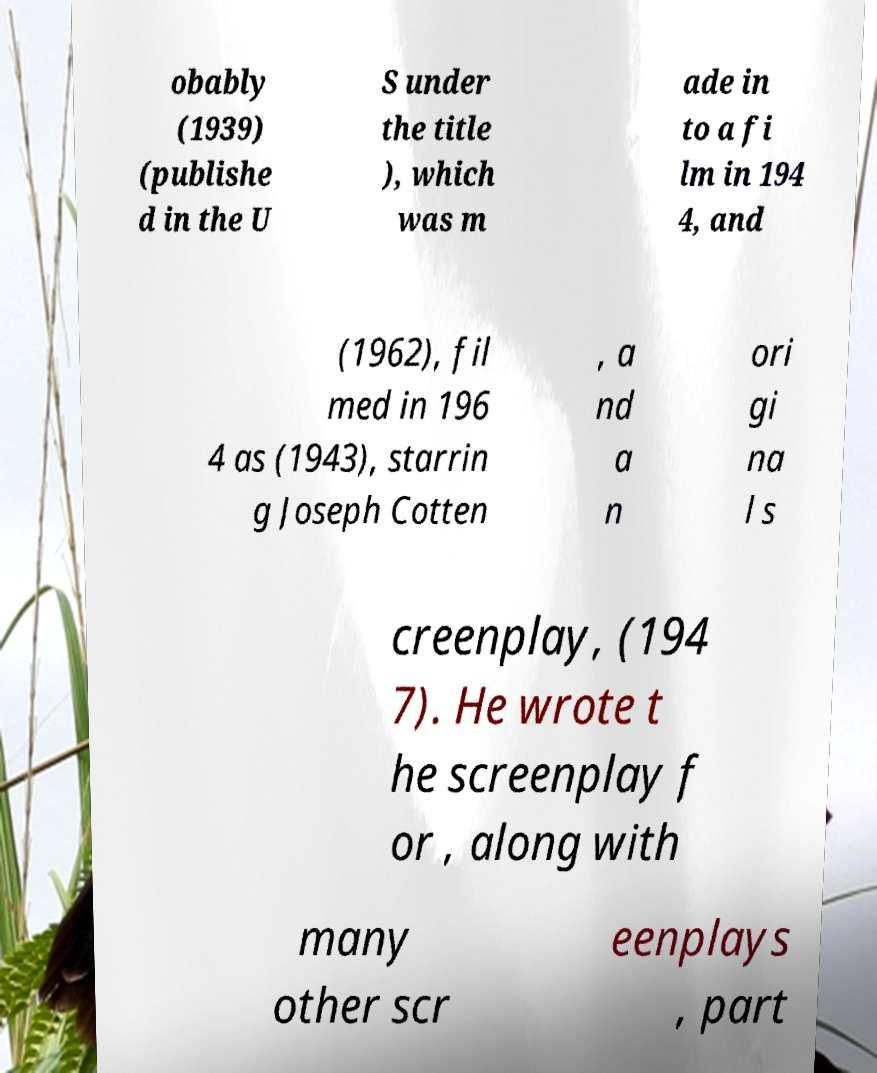For documentation purposes, I need the text within this image transcribed. Could you provide that? obably (1939) (publishe d in the U S under the title ), which was m ade in to a fi lm in 194 4, and (1962), fil med in 196 4 as (1943), starrin g Joseph Cotten , a nd a n ori gi na l s creenplay, (194 7). He wrote t he screenplay f or , along with many other scr eenplays , part 